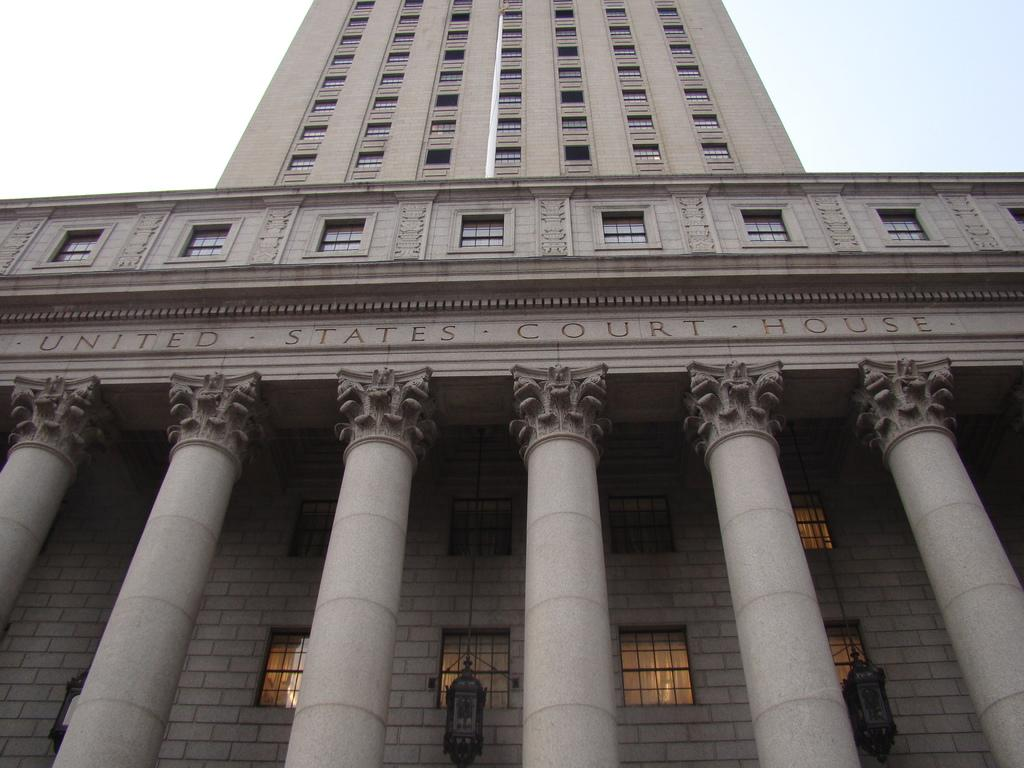What type of structure is present in the image? There is a building in the image. What can be found inside the building? There are pillows visible in the image. What architectural feature is present in the building? There are windows in the image. What is visible in the background of the image? The sky is visible in the background of the image. Can you tell me how many zebras are visible in the image? There are no zebras present in the image. What type of pet does the son in the image have? There is no son or pet mentioned in the image. 